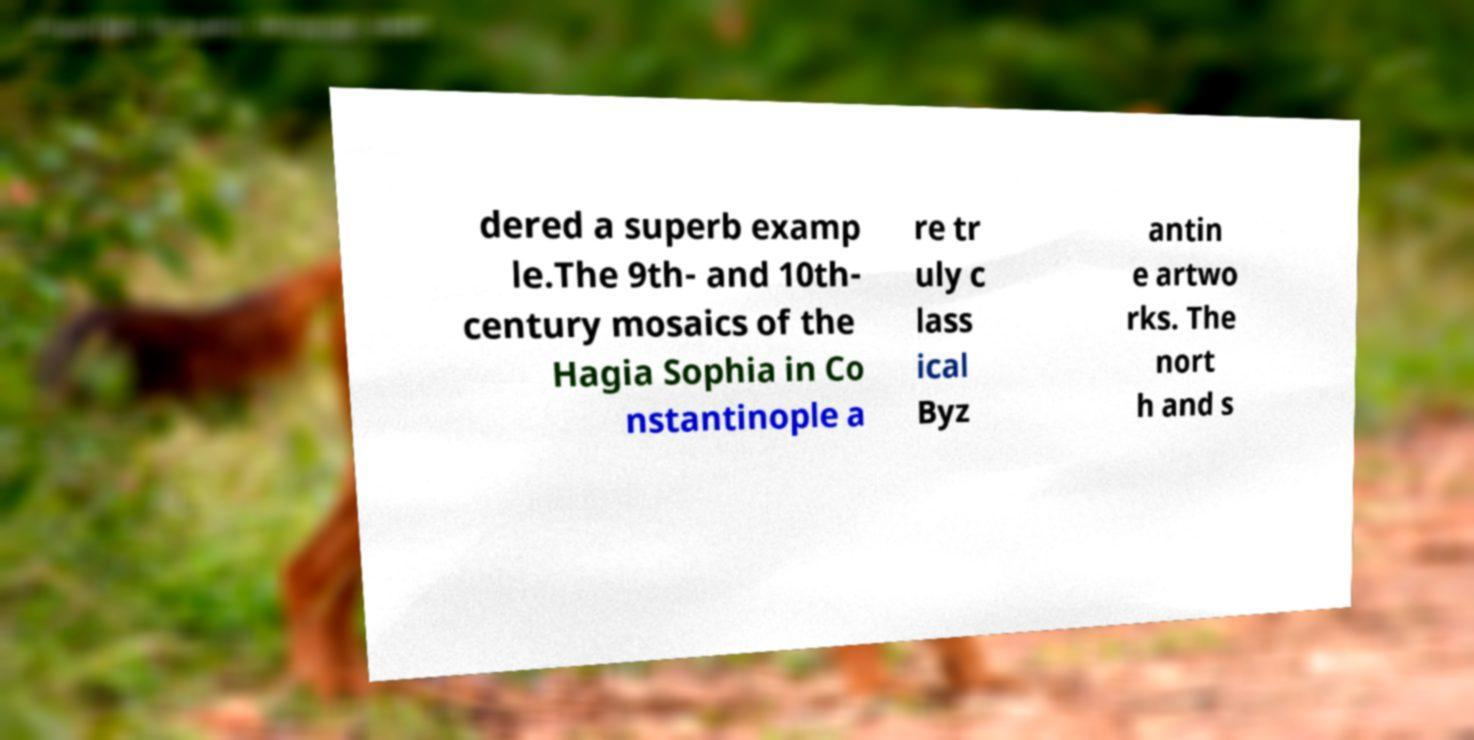For documentation purposes, I need the text within this image transcribed. Could you provide that? dered a superb examp le.The 9th- and 10th- century mosaics of the Hagia Sophia in Co nstantinople a re tr uly c lass ical Byz antin e artwo rks. The nort h and s 